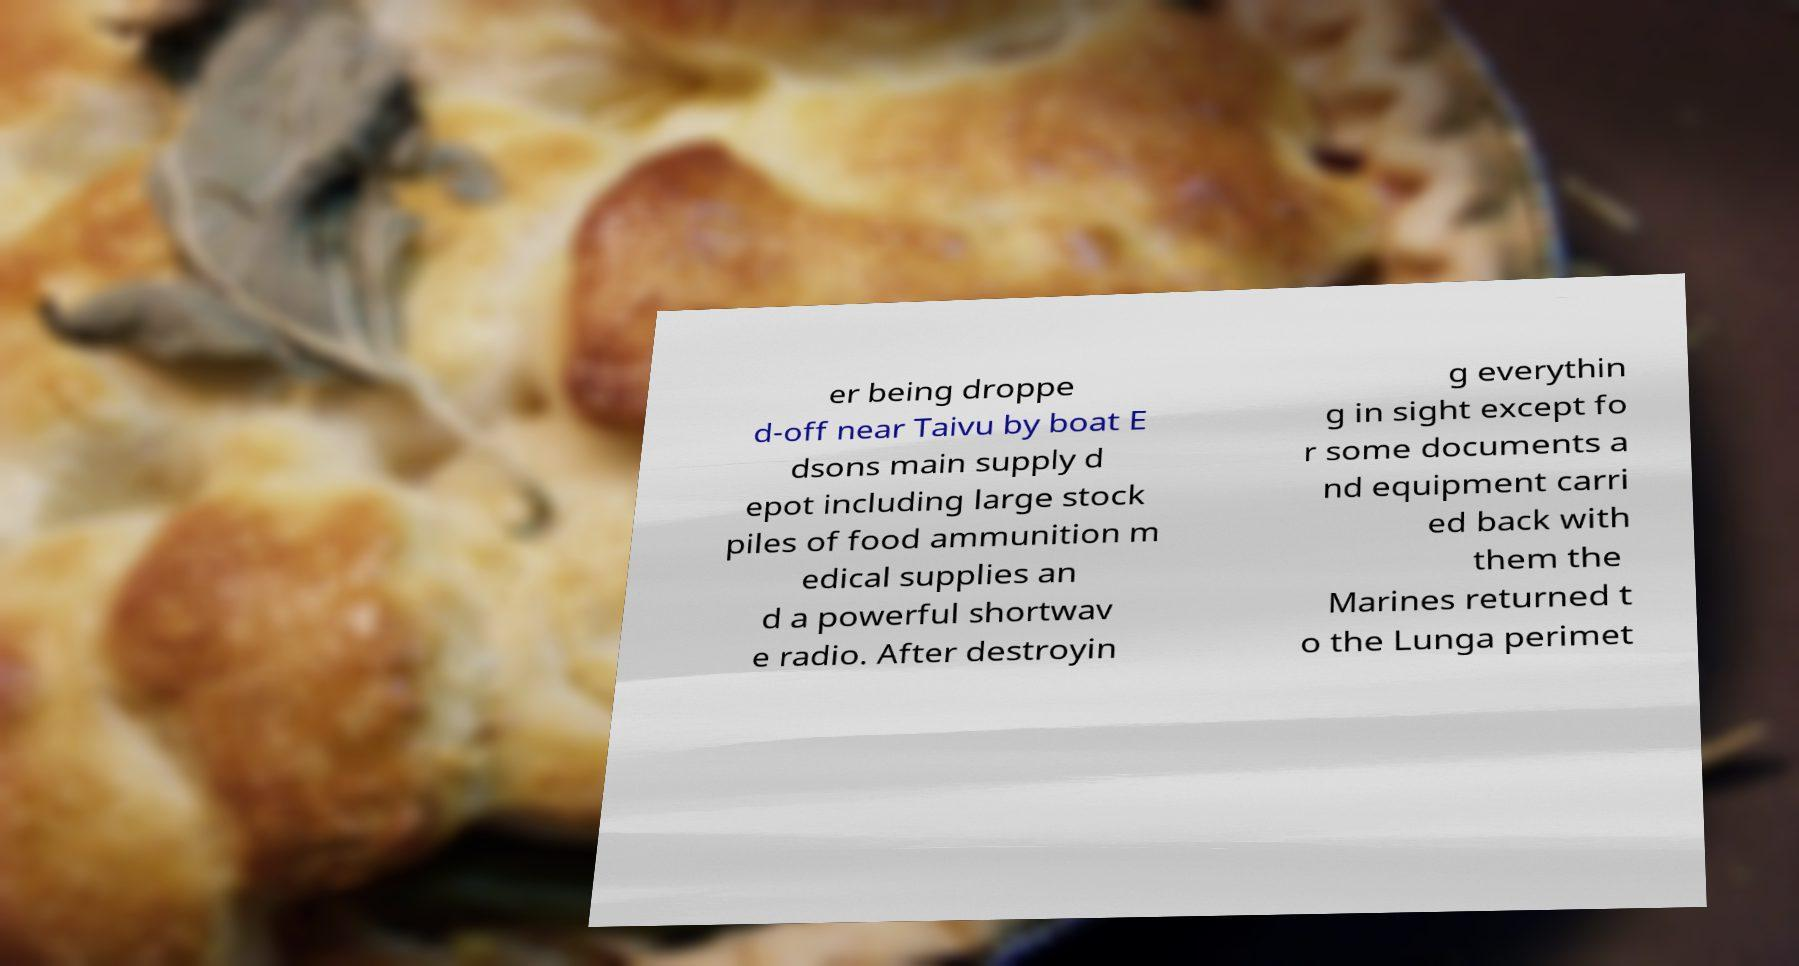Could you extract and type out the text from this image? er being droppe d-off near Taivu by boat E dsons main supply d epot including large stock piles of food ammunition m edical supplies an d a powerful shortwav e radio. After destroyin g everythin g in sight except fo r some documents a nd equipment carri ed back with them the Marines returned t o the Lunga perimet 